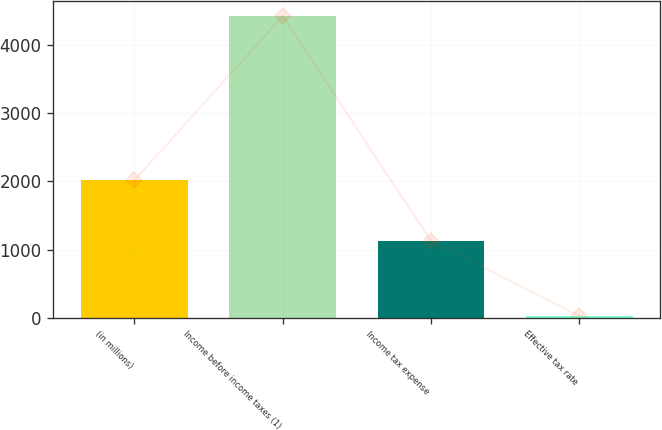<chart> <loc_0><loc_0><loc_500><loc_500><bar_chart><fcel>(in millions)<fcel>Income before income taxes (1)<fcel>Income tax expense<fcel>Effective tax rate<nl><fcel>2014<fcel>4425<fcel>1131<fcel>25.6<nl></chart> 